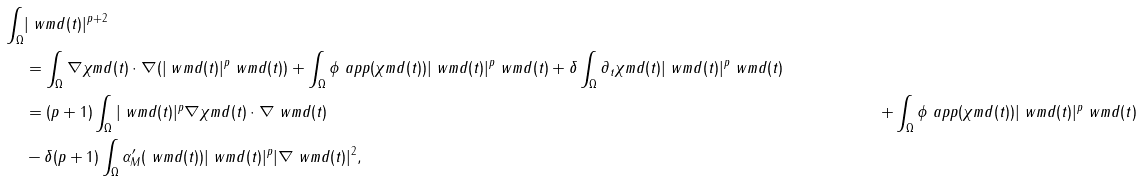<formula> <loc_0><loc_0><loc_500><loc_500>\int _ { \Omega } & | \ w m d ( t ) | ^ { p + 2 } \\ & = \int _ { \Omega } \nabla \chi m d ( t ) \cdot \nabla ( | \ w m d ( t ) | ^ { p } \ w m d ( t ) ) + \int _ { \Omega } \phi _ { \ } a p p ( \chi m d ( t ) ) | \ w m d ( t ) | ^ { p } \ w m d ( t ) + \delta \int _ { \Omega } \partial _ { t } \chi m d ( t ) | \ w m d ( t ) | ^ { p } \ w m d ( t ) \\ & = ( p + 1 ) \int _ { \Omega } | \ w m d ( t ) | ^ { p } \nabla \chi m d ( t ) \cdot \nabla \ w m d ( t ) & + \int _ { \Omega } \phi _ { \ } a p p ( \chi m d ( t ) ) | \ w m d ( t ) | ^ { p } \ w m d ( t ) \\ & - \delta ( p + 1 ) \int _ { \Omega } \alpha _ { M } ^ { \prime } ( \ w m d ( t ) ) | \ w m d ( t ) | ^ { p } | \nabla \ w m d ( t ) | ^ { 2 } ,</formula> 